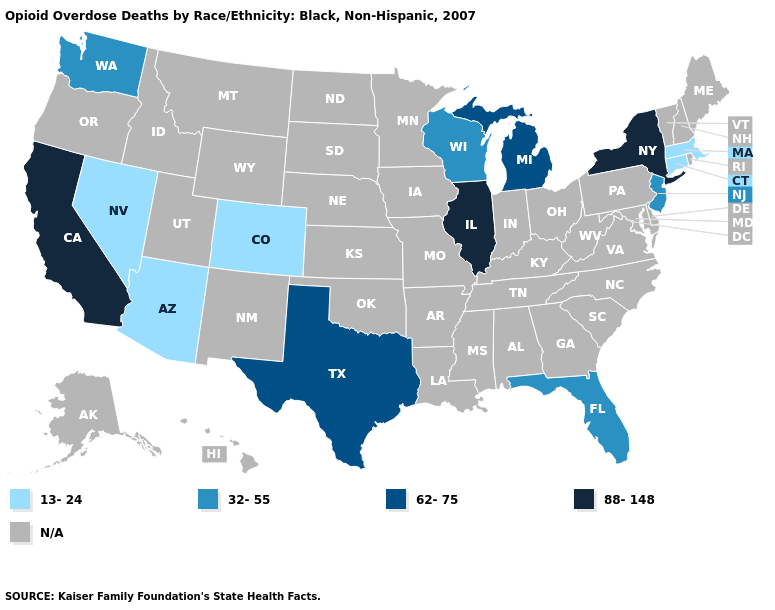Which states have the highest value in the USA?
Be succinct. California, Illinois, New York. What is the value of South Carolina?
Write a very short answer. N/A. Does the first symbol in the legend represent the smallest category?
Answer briefly. Yes. What is the lowest value in the MidWest?
Keep it brief. 32-55. What is the lowest value in the MidWest?
Be succinct. 32-55. Name the states that have a value in the range 13-24?
Answer briefly. Arizona, Colorado, Connecticut, Massachusetts, Nevada. Among the states that border New Mexico , does Arizona have the highest value?
Answer briefly. No. Does the map have missing data?
Quick response, please. Yes. Name the states that have a value in the range N/A?
Give a very brief answer. Alabama, Alaska, Arkansas, Delaware, Georgia, Hawaii, Idaho, Indiana, Iowa, Kansas, Kentucky, Louisiana, Maine, Maryland, Minnesota, Mississippi, Missouri, Montana, Nebraska, New Hampshire, New Mexico, North Carolina, North Dakota, Ohio, Oklahoma, Oregon, Pennsylvania, Rhode Island, South Carolina, South Dakota, Tennessee, Utah, Vermont, Virginia, West Virginia, Wyoming. Which states hav the highest value in the MidWest?
Keep it brief. Illinois. What is the value of Washington?
Quick response, please. 32-55. How many symbols are there in the legend?
Write a very short answer. 5. What is the highest value in states that border Arizona?
Answer briefly. 88-148. 